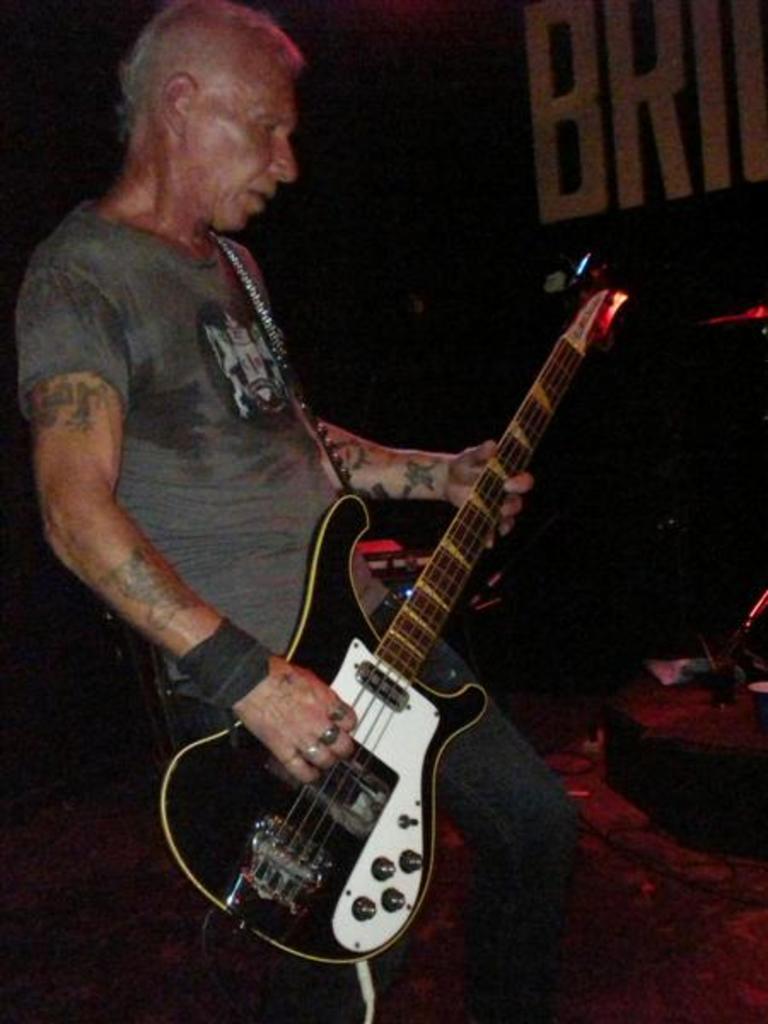In one or two sentences, can you explain what this image depicts? There is a man green t-shirt is standing and playing a guitar. To his hand there is a band. And some rings to his fingers. And to the right side there is an item. 